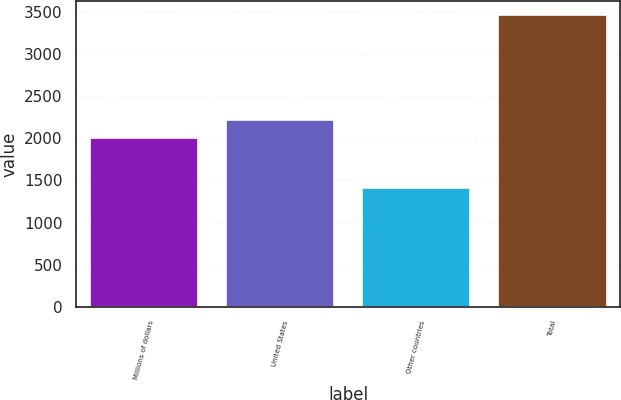Convert chart. <chart><loc_0><loc_0><loc_500><loc_500><bar_chart><fcel>Millions of dollars<fcel>United States<fcel>Other countries<fcel>Total<nl><fcel>2006<fcel>2210.5<fcel>1413<fcel>3458<nl></chart> 